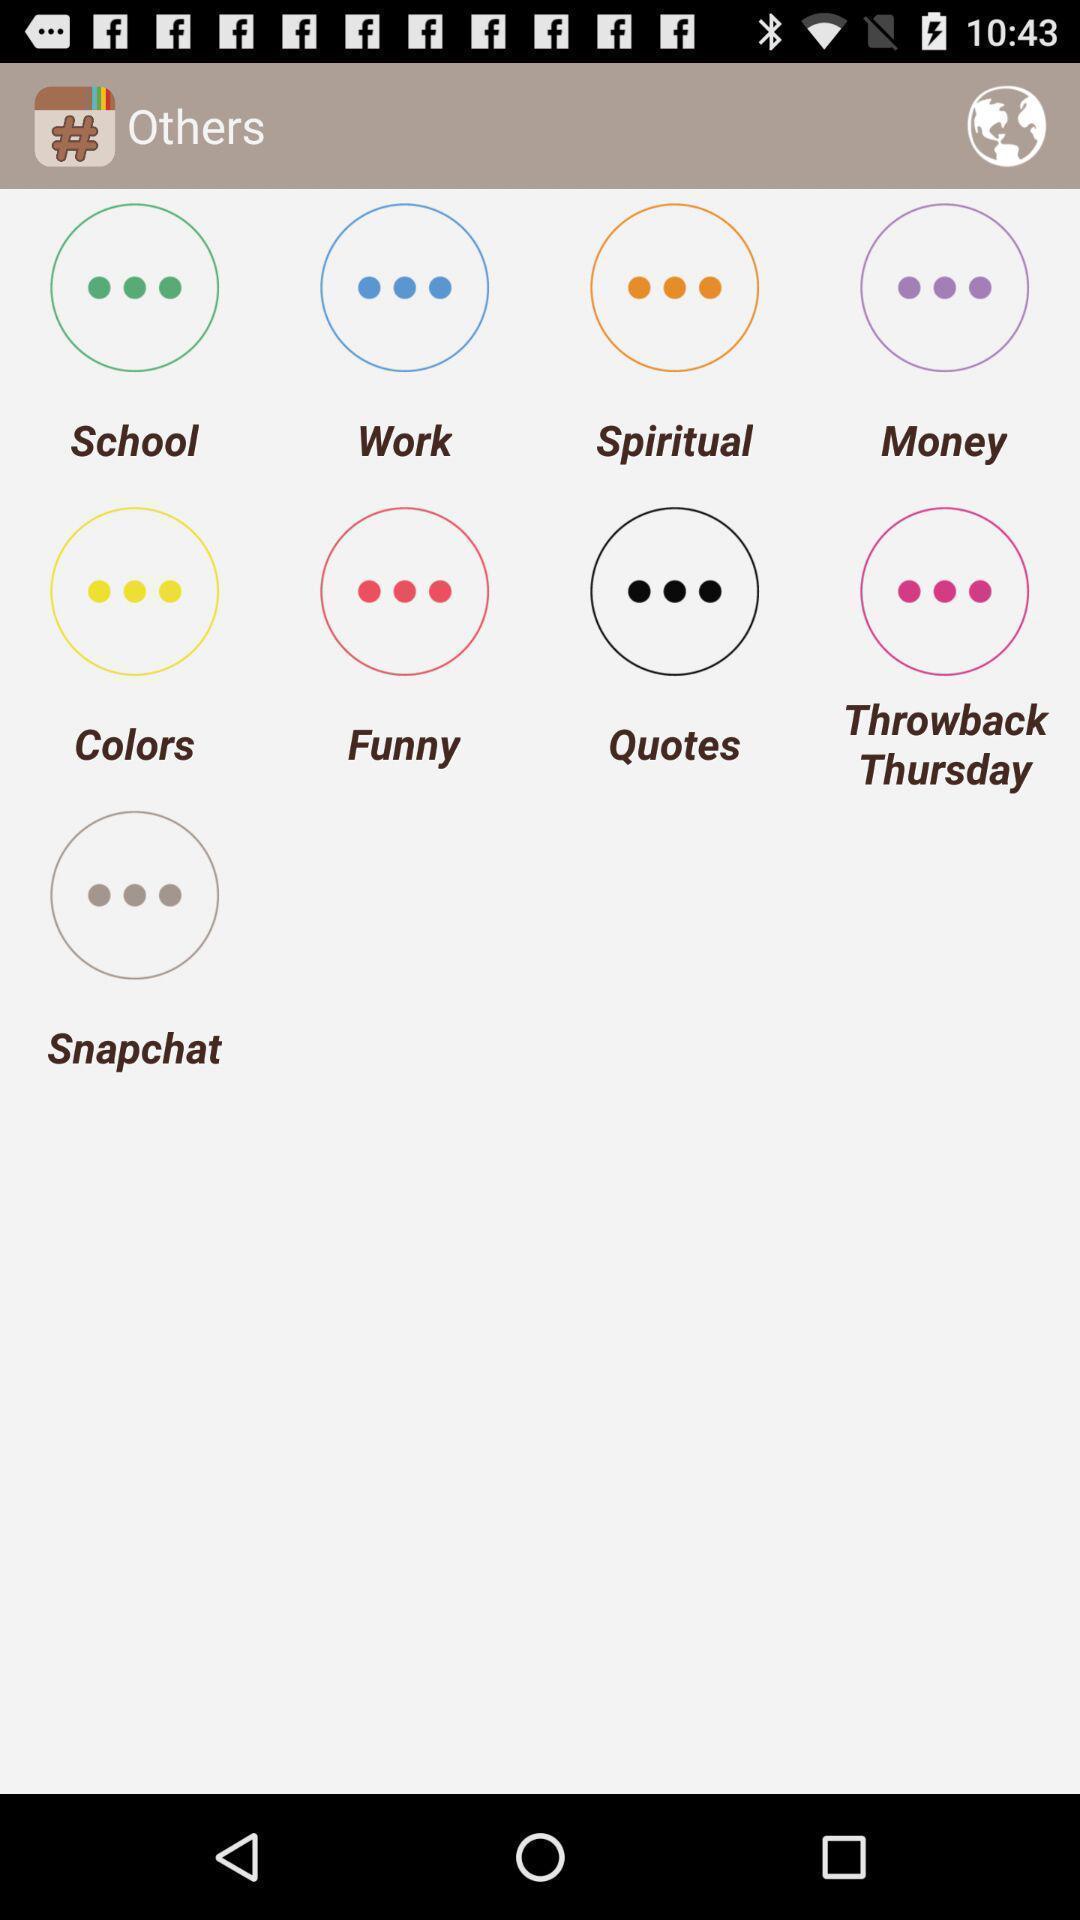What can you discern from this picture? Page displaying multiple tags in a social app. 